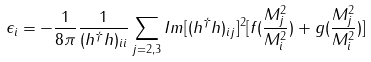<formula> <loc_0><loc_0><loc_500><loc_500>\epsilon _ { i } = - \frac { 1 } { 8 \pi } \frac { 1 } { ( h ^ { \dagger } h ) _ { i i } } \sum _ { j = 2 , 3 } I m [ ( h ^ { \dagger } h ) _ { i j } ] ^ { 2 } [ f ( \frac { M ^ { 2 } _ { j } } { M ^ { 2 } _ { i } } ) + g ( \frac { M ^ { 2 } _ { j } } { M ^ { 2 } _ { i } } ) ]</formula> 